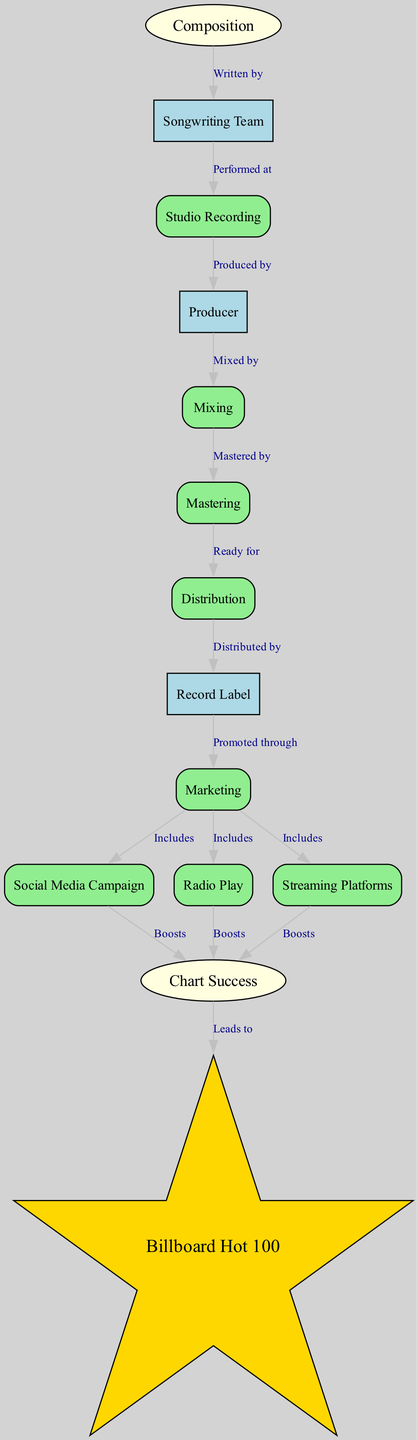What is the first step in the lifecycle of a hit song? The diagram shows that the first step in the lifecycle is "Composition," indicating that creation is the initial phase before anything else occurs.
Answer: Composition How many nodes are present in the diagram? By counting the distinct elements represented in the diagram, we identify 14 unique nodes.
Answer: 14 Which team is responsible for writing the song? The edge labeled "Written by" connects the "Composition" node to the "Songwriting Team," indicating that this team is responsible for writing the song.
Answer: Songwriting Team What follows studio recording in the song creation process? According to the diagram, the "Studio Recording" node connects to the "Producer" node with the label "Produced by," showing that the next step after recording is producing the song.
Answer: Producer Which marketing strategy boosts chart success alongside radio play? The edge labeled "Boosts" shows direct connections from both "Social Media Campaign" and "Radio Play" to "Chart Success," indicating they both enhance the song's prominence on charts.
Answer: Social Media Campaign How does a hit song reach the Billboard Hot 100? The diagram illustrates that "Chart Success" leads to "Billboard Hot 100," indicating that achieving chart success is directly responsible for reaching this prestigious list.
Answer: Billboard Hot 100 What do mastering and distribution lead to in the production process? The flow from "Mastering" to "Distribution" with the label "Ready for" and then from "Distribution" to "Record Label" shows that these phases are crucial, as they prepare the song for public release.
Answer: Distribution Which promotional method is included by the marketing phase? The diagram indicates multiple edges from "Marketing" to nodes like "Social Media Campaign," "Radio Play," and "Streaming Platforms," showing that all these are part of the promotional strategy.
Answer: Social Media Campaign What is the role of mixing in the song production process? The edge from "Mixing" to "Mastering" labeled "Mastered by" shows that mixing is an essential step that comes before mastering, focusing on blending sound elements for quality.
Answer: Mastering 